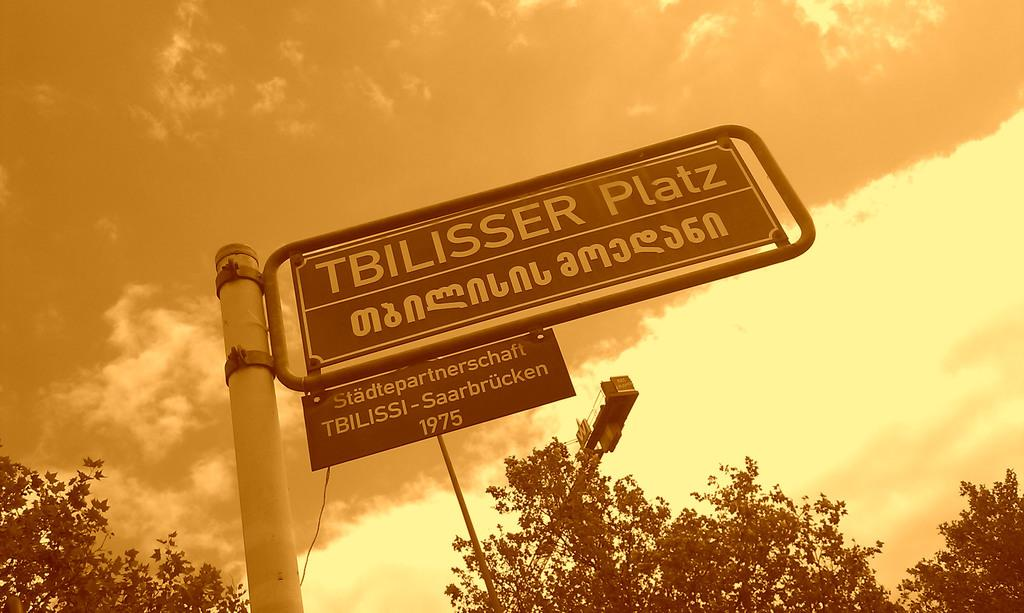What is written on the board in the image? There is a board with text in the image, but we cannot determine the exact text from the image. What type of machinery is present in the image? There is a crane in the image. What is the rope used for in the image? The rope is visible in the image, but its purpose cannot be determined without additional context. What type of vegetation is present in the image? There are trees in the image. What is visible in the sky in the image? There are clouds in the sky in the image. Where is the boy sitting and drinking in the image? There is no boy or drink present in the image. What type of power source is used to operate the crane in the image? The image does not provide information about the power source for the crane. 